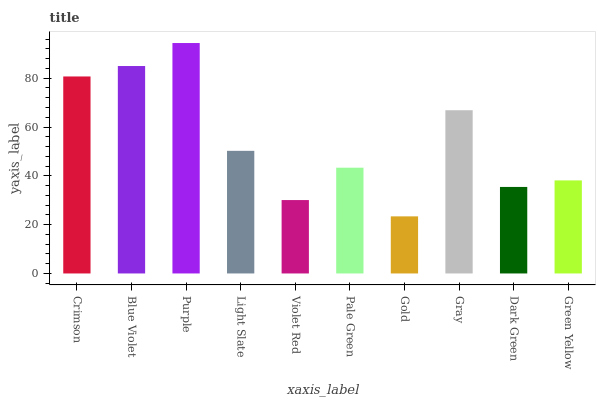Is Gold the minimum?
Answer yes or no. Yes. Is Purple the maximum?
Answer yes or no. Yes. Is Blue Violet the minimum?
Answer yes or no. No. Is Blue Violet the maximum?
Answer yes or no. No. Is Blue Violet greater than Crimson?
Answer yes or no. Yes. Is Crimson less than Blue Violet?
Answer yes or no. Yes. Is Crimson greater than Blue Violet?
Answer yes or no. No. Is Blue Violet less than Crimson?
Answer yes or no. No. Is Light Slate the high median?
Answer yes or no. Yes. Is Pale Green the low median?
Answer yes or no. Yes. Is Dark Green the high median?
Answer yes or no. No. Is Violet Red the low median?
Answer yes or no. No. 